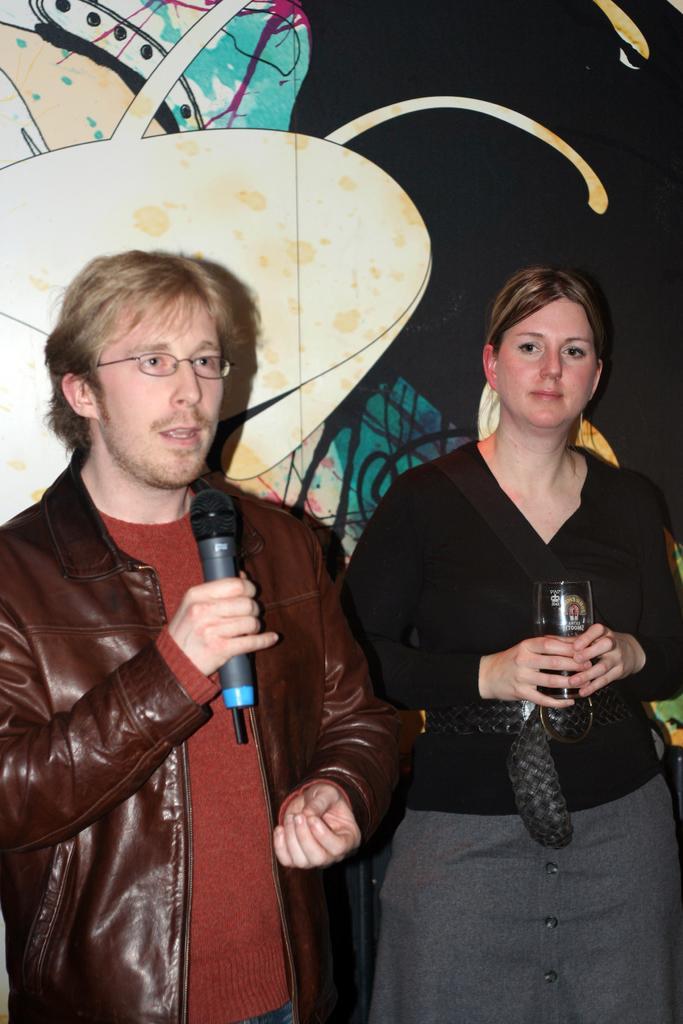Please provide a concise description of this image. There is a man holding a mic and wearing a specs. Near to him a lady is standing and holding something in the hand. In the back there are some decorations. 